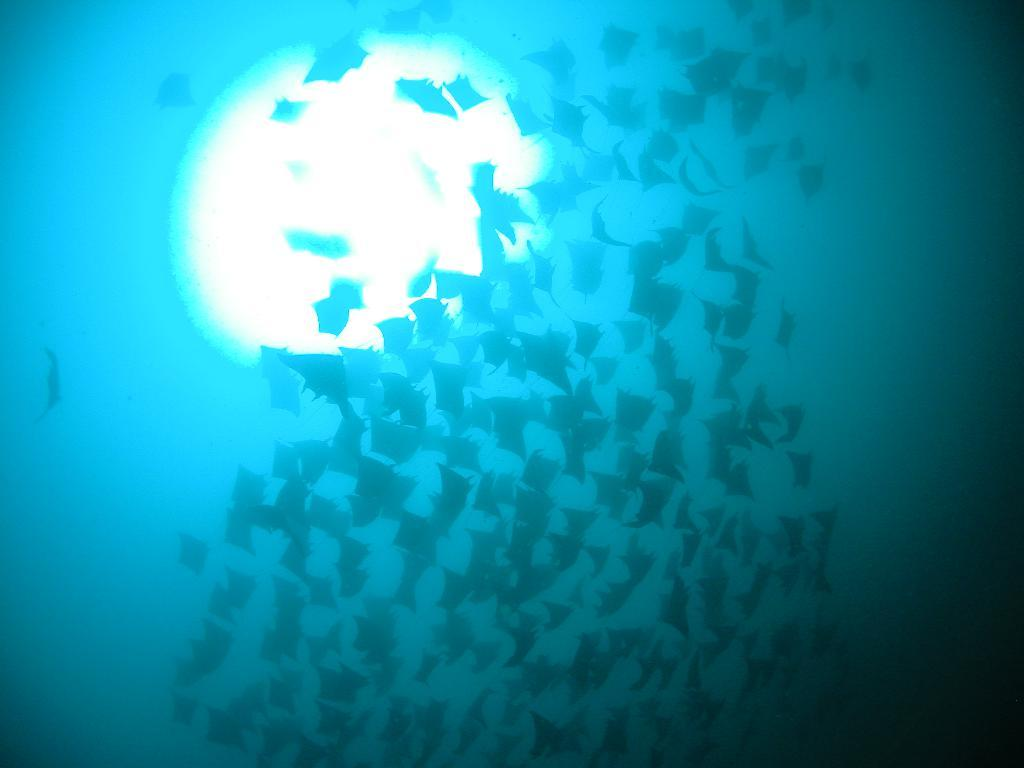What type of animals can be seen in the image? There are a few birds in the image. What is the color of the background in the image? The background of the image is blue in color. Can you describe the lighting in the image? There is visible light in the image. How does the person in the image help the grain to grow? There is no person present in the image, and therefore no such activity can be observed. Can you tell me how many sea creatures are visible in the image? There are no sea creatures present in the image; it features a few birds. 